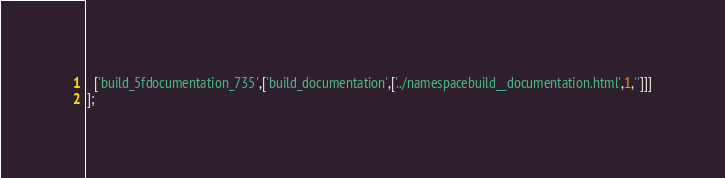Convert code to text. <code><loc_0><loc_0><loc_500><loc_500><_JavaScript_>  ['build_5fdocumentation_735',['build_documentation',['../namespacebuild__documentation.html',1,'']]]
];
</code> 